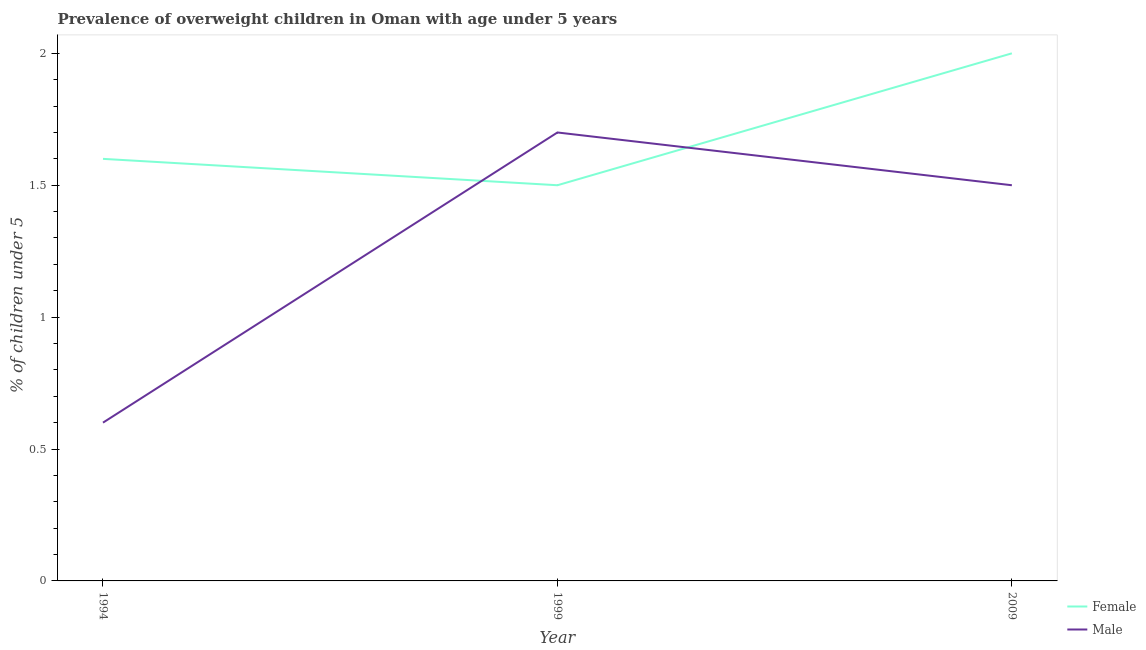Does the line corresponding to percentage of obese female children intersect with the line corresponding to percentage of obese male children?
Offer a very short reply. Yes. What is the percentage of obese female children in 1994?
Provide a short and direct response. 1.6. Across all years, what is the maximum percentage of obese female children?
Ensure brevity in your answer.  2. Across all years, what is the minimum percentage of obese male children?
Offer a very short reply. 0.6. In which year was the percentage of obese male children minimum?
Your response must be concise. 1994. What is the total percentage of obese female children in the graph?
Provide a short and direct response. 5.1. What is the difference between the percentage of obese female children in 1999 and that in 2009?
Your response must be concise. -0.5. What is the difference between the percentage of obese male children in 2009 and the percentage of obese female children in 1994?
Offer a terse response. -0.1. What is the average percentage of obese male children per year?
Provide a succinct answer. 1.27. In the year 1994, what is the difference between the percentage of obese female children and percentage of obese male children?
Ensure brevity in your answer.  1. In how many years, is the percentage of obese male children greater than 0.8 %?
Offer a terse response. 2. What is the ratio of the percentage of obese male children in 1999 to that in 2009?
Your answer should be very brief. 1.13. Is the difference between the percentage of obese female children in 1994 and 2009 greater than the difference between the percentage of obese male children in 1994 and 2009?
Ensure brevity in your answer.  Yes. What is the difference between the highest and the second highest percentage of obese female children?
Ensure brevity in your answer.  0.4. What is the difference between the highest and the lowest percentage of obese female children?
Your answer should be compact. 0.5. Is the sum of the percentage of obese female children in 1994 and 1999 greater than the maximum percentage of obese male children across all years?
Provide a succinct answer. Yes. Is the percentage of obese female children strictly greater than the percentage of obese male children over the years?
Offer a terse response. No. Is the percentage of obese female children strictly less than the percentage of obese male children over the years?
Keep it short and to the point. No. What is the difference between two consecutive major ticks on the Y-axis?
Your response must be concise. 0.5. Are the values on the major ticks of Y-axis written in scientific E-notation?
Your response must be concise. No. Does the graph contain any zero values?
Offer a terse response. No. How many legend labels are there?
Give a very brief answer. 2. How are the legend labels stacked?
Keep it short and to the point. Vertical. What is the title of the graph?
Your answer should be compact. Prevalence of overweight children in Oman with age under 5 years. What is the label or title of the Y-axis?
Keep it short and to the point.  % of children under 5. What is the  % of children under 5 of Female in 1994?
Offer a very short reply. 1.6. What is the  % of children under 5 in Male in 1994?
Make the answer very short. 0.6. What is the  % of children under 5 in Female in 1999?
Your answer should be compact. 1.5. What is the  % of children under 5 of Male in 1999?
Provide a succinct answer. 1.7. What is the  % of children under 5 of Female in 2009?
Offer a terse response. 2. Across all years, what is the maximum  % of children under 5 in Female?
Make the answer very short. 2. Across all years, what is the maximum  % of children under 5 of Male?
Give a very brief answer. 1.7. Across all years, what is the minimum  % of children under 5 in Female?
Give a very brief answer. 1.5. Across all years, what is the minimum  % of children under 5 in Male?
Give a very brief answer. 0.6. What is the total  % of children under 5 in Female in the graph?
Your answer should be very brief. 5.1. What is the total  % of children under 5 in Male in the graph?
Keep it short and to the point. 3.8. What is the difference between the  % of children under 5 of Male in 1994 and that in 2009?
Provide a short and direct response. -0.9. What is the difference between the  % of children under 5 in Female in 1999 and that in 2009?
Ensure brevity in your answer.  -0.5. What is the difference between the  % of children under 5 in Female in 1994 and the  % of children under 5 in Male in 1999?
Offer a very short reply. -0.1. What is the difference between the  % of children under 5 of Female in 1994 and the  % of children under 5 of Male in 2009?
Offer a very short reply. 0.1. What is the average  % of children under 5 in Male per year?
Keep it short and to the point. 1.27. What is the ratio of the  % of children under 5 of Female in 1994 to that in 1999?
Make the answer very short. 1.07. What is the ratio of the  % of children under 5 in Male in 1994 to that in 1999?
Provide a succinct answer. 0.35. What is the ratio of the  % of children under 5 of Female in 1994 to that in 2009?
Your response must be concise. 0.8. What is the ratio of the  % of children under 5 of Male in 1994 to that in 2009?
Keep it short and to the point. 0.4. What is the ratio of the  % of children under 5 of Female in 1999 to that in 2009?
Your response must be concise. 0.75. What is the ratio of the  % of children under 5 in Male in 1999 to that in 2009?
Provide a succinct answer. 1.13. What is the difference between the highest and the second highest  % of children under 5 of Female?
Provide a succinct answer. 0.4. What is the difference between the highest and the lowest  % of children under 5 in Male?
Your answer should be very brief. 1.1. 